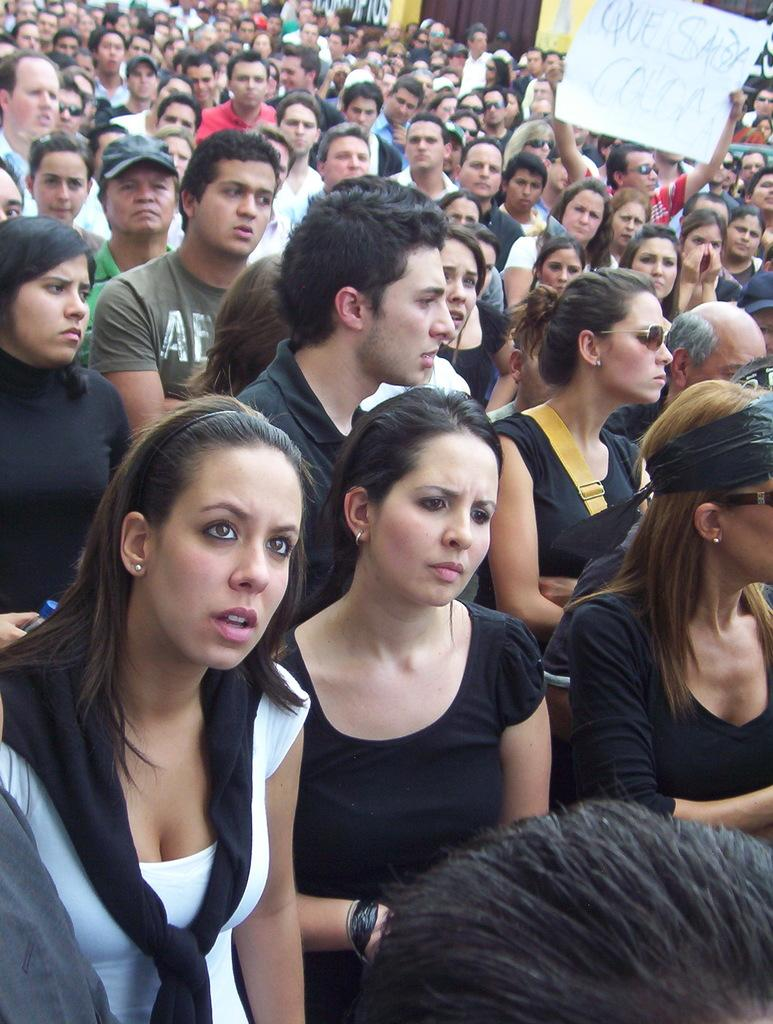What is the main subject of the image? The main subject of the image is a crowd. Can you describe any specific individuals in the crowd? Yes, there is a person wearing goggles and holding a poster, as well as a person wearing a cap. What type of tax is being discussed on the plate in the image? There is no plate present in the image, and therefore no discussion of taxes can be observed. 